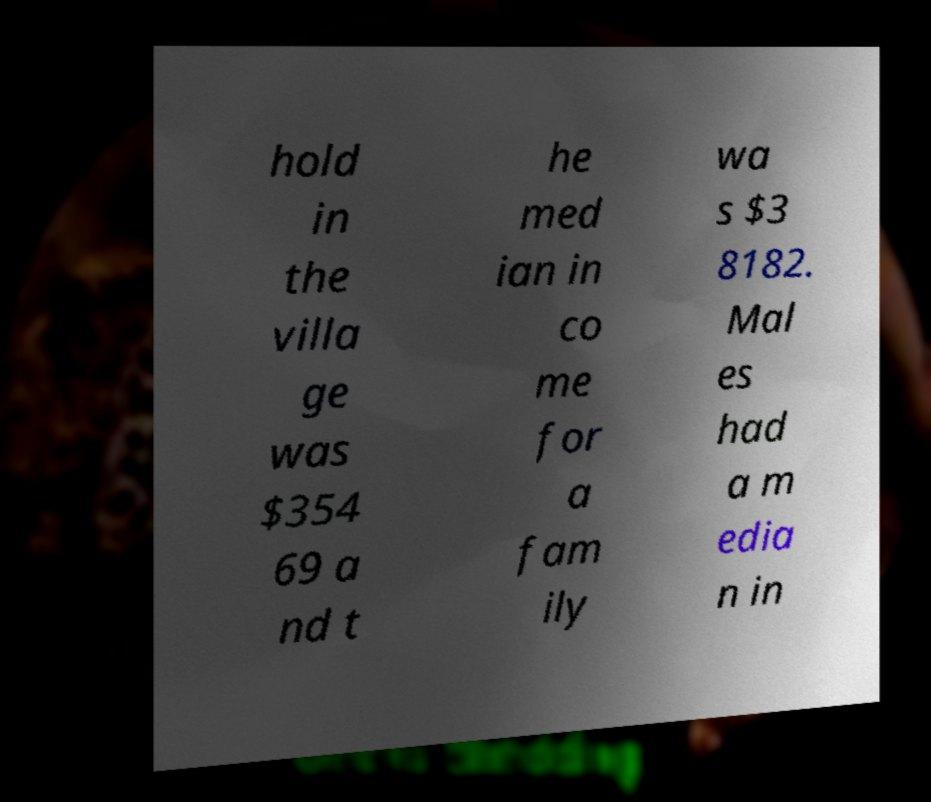Can you accurately transcribe the text from the provided image for me? hold in the villa ge was $354 69 a nd t he med ian in co me for a fam ily wa s $3 8182. Mal es had a m edia n in 